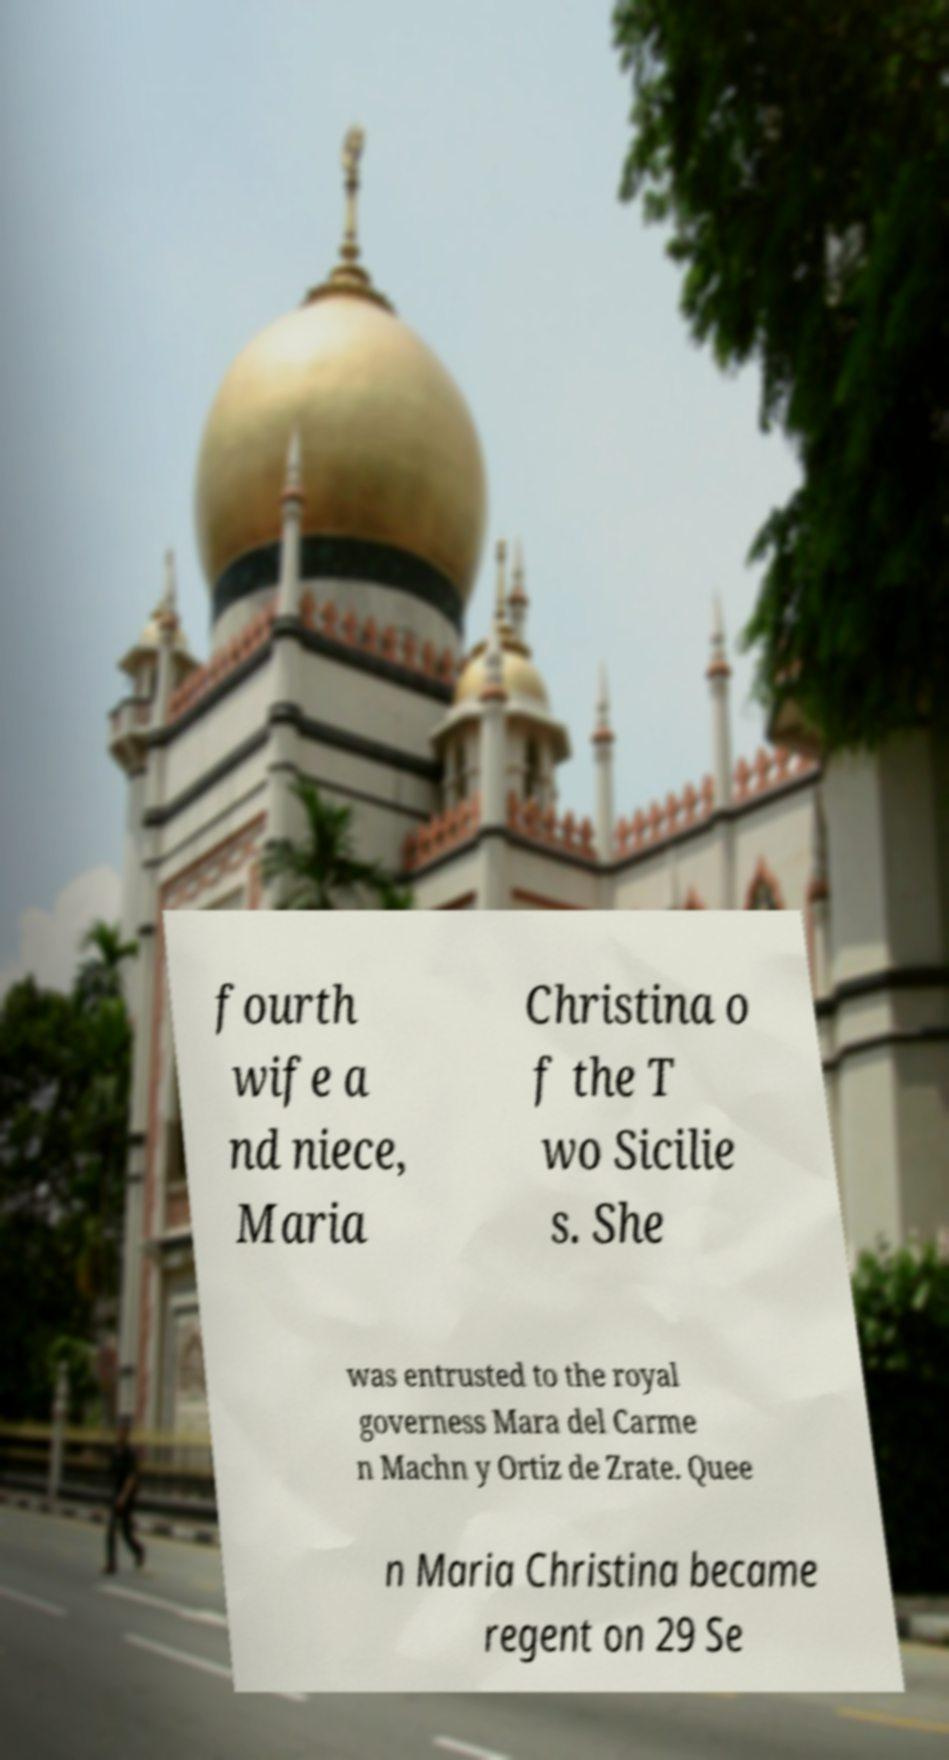Could you assist in decoding the text presented in this image and type it out clearly? fourth wife a nd niece, Maria Christina o f the T wo Sicilie s. She was entrusted to the royal governess Mara del Carme n Machn y Ortiz de Zrate. Quee n Maria Christina became regent on 29 Se 